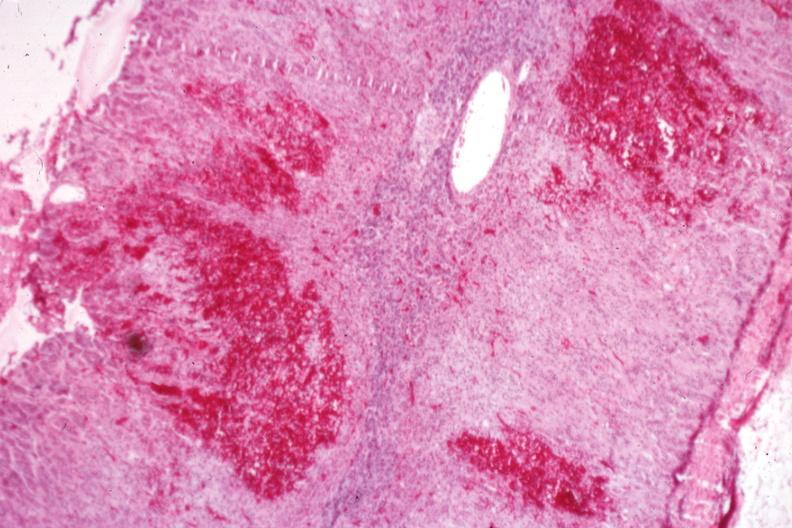what is present?
Answer the question using a single word or phrase. Endocrine 